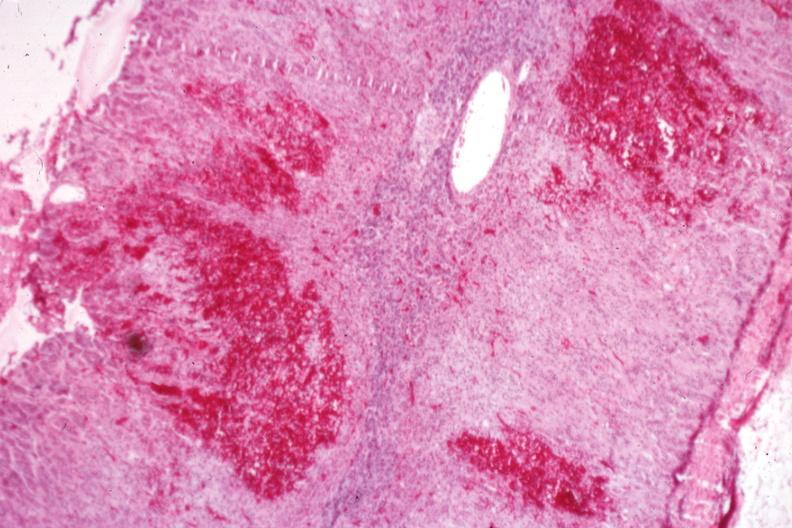what is present?
Answer the question using a single word or phrase. Endocrine 